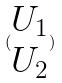<formula> <loc_0><loc_0><loc_500><loc_500>( \begin{matrix} U _ { 1 } \\ U _ { 2 } \end{matrix} )</formula> 